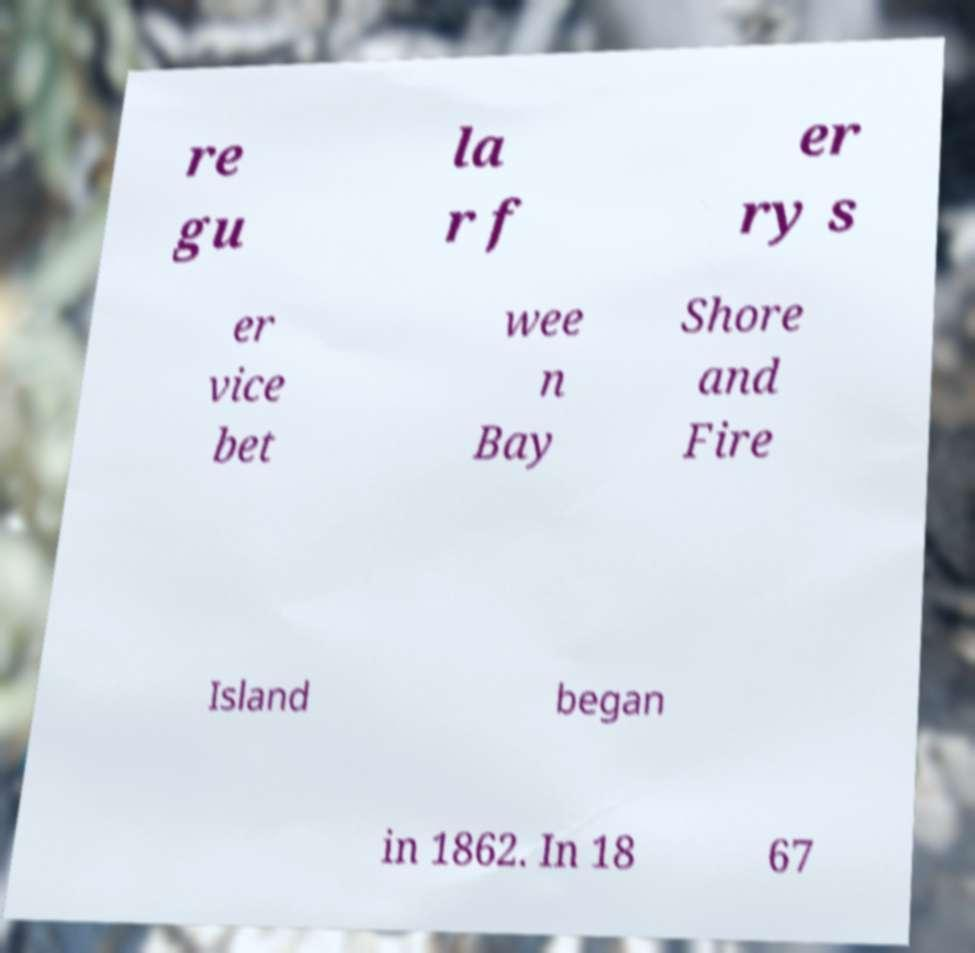Please identify and transcribe the text found in this image. re gu la r f er ry s er vice bet wee n Bay Shore and Fire Island began in 1862. In 18 67 